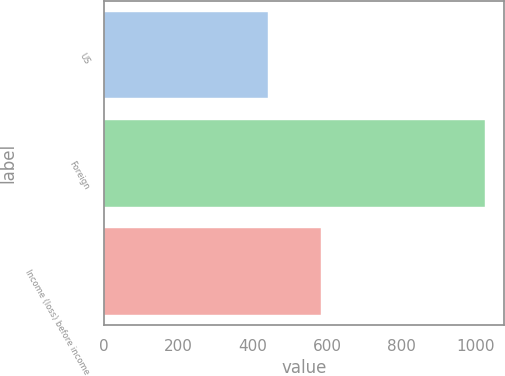Convert chart to OTSL. <chart><loc_0><loc_0><loc_500><loc_500><bar_chart><fcel>US<fcel>Foreign<fcel>Income (loss) before income<nl><fcel>440<fcel>1024<fcel>584<nl></chart> 